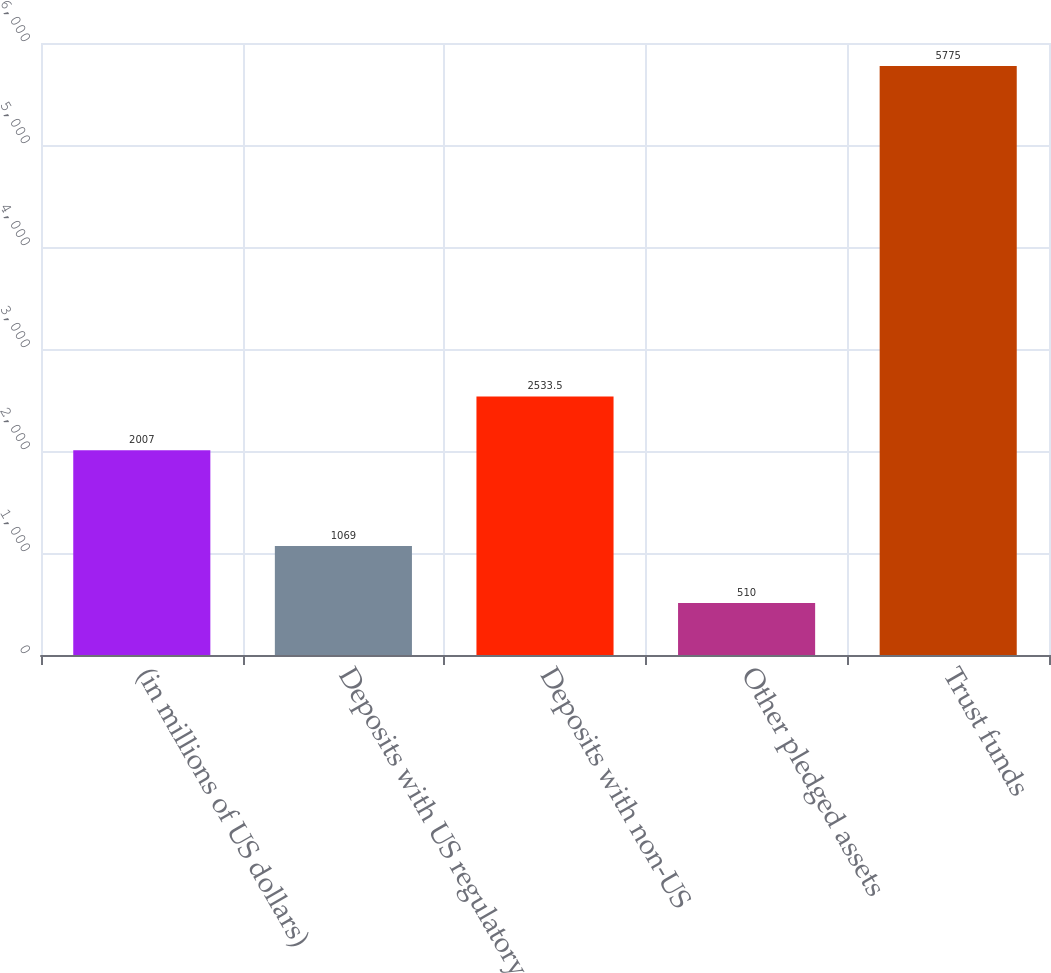Convert chart. <chart><loc_0><loc_0><loc_500><loc_500><bar_chart><fcel>(in millions of US dollars)<fcel>Deposits with US regulatory<fcel>Deposits with non-US<fcel>Other pledged assets<fcel>Trust funds<nl><fcel>2007<fcel>1069<fcel>2533.5<fcel>510<fcel>5775<nl></chart> 